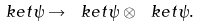<formula> <loc_0><loc_0><loc_500><loc_500>\ k e t { \psi } \rightarrow \ k e t { \psi } \otimes \ k e t { \psi } .</formula> 